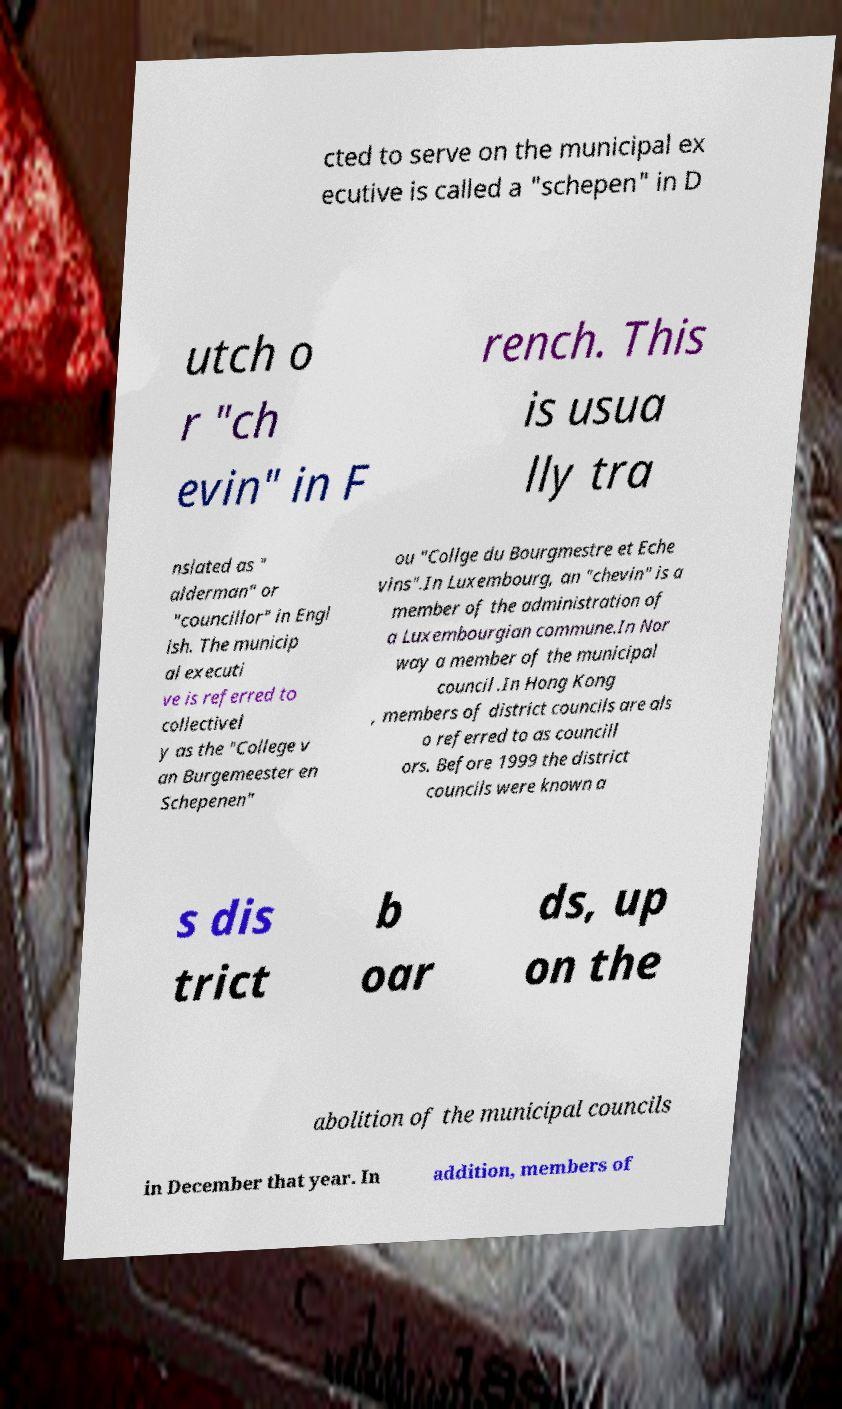I need the written content from this picture converted into text. Can you do that? cted to serve on the municipal ex ecutive is called a "schepen" in D utch o r "ch evin" in F rench. This is usua lly tra nslated as " alderman" or "councillor" in Engl ish. The municip al executi ve is referred to collectivel y as the "College v an Burgemeester en Schepenen" ou "Collge du Bourgmestre et Eche vins".In Luxembourg, an "chevin" is a member of the administration of a Luxembourgian commune.In Nor way a member of the municipal council .In Hong Kong , members of district councils are als o referred to as councill ors. Before 1999 the district councils were known a s dis trict b oar ds, up on the abolition of the municipal councils in December that year. In addition, members of 